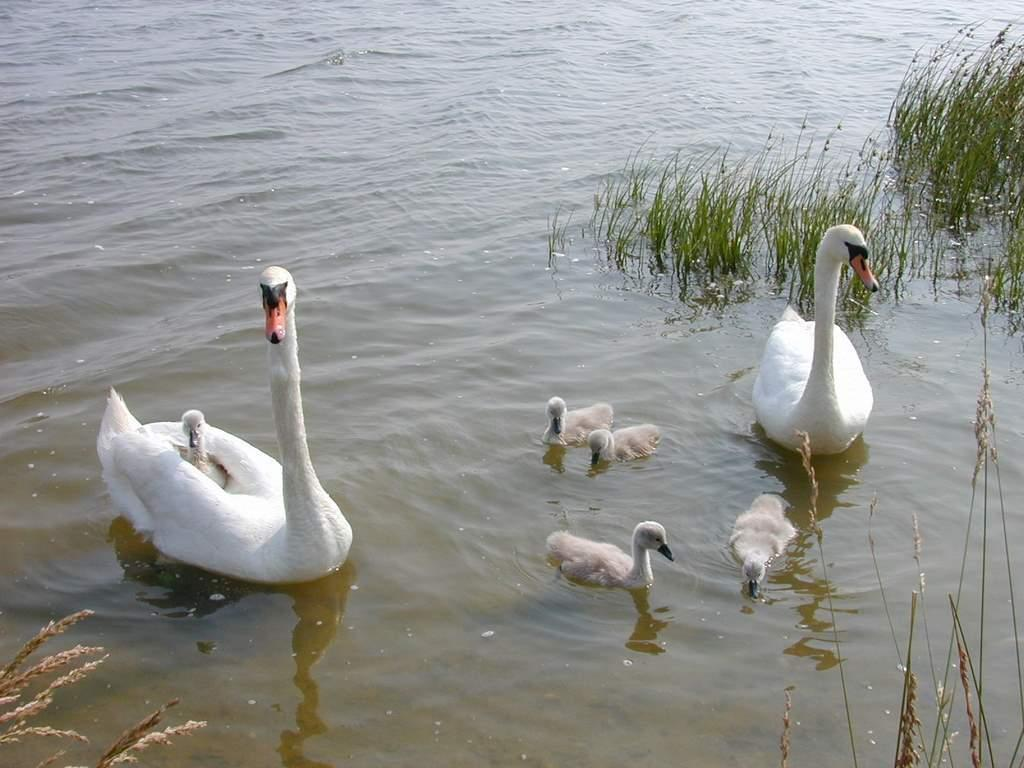What type of animals can be seen in the image? There are swans and ducks in the image. What are the swans and ducks doing in the image? The swans and ducks are swimming in the water. What is the primary element in which the swans and ducks are situated? The swans and ducks are swimming in water, which might be in a pond. Can you describe the surrounding environment in the image? There is grass visible in the right top of the picture. What type of liquid is the wren drinking in the image? There is no wren present in the image, and therefore no such activity can be observed. 